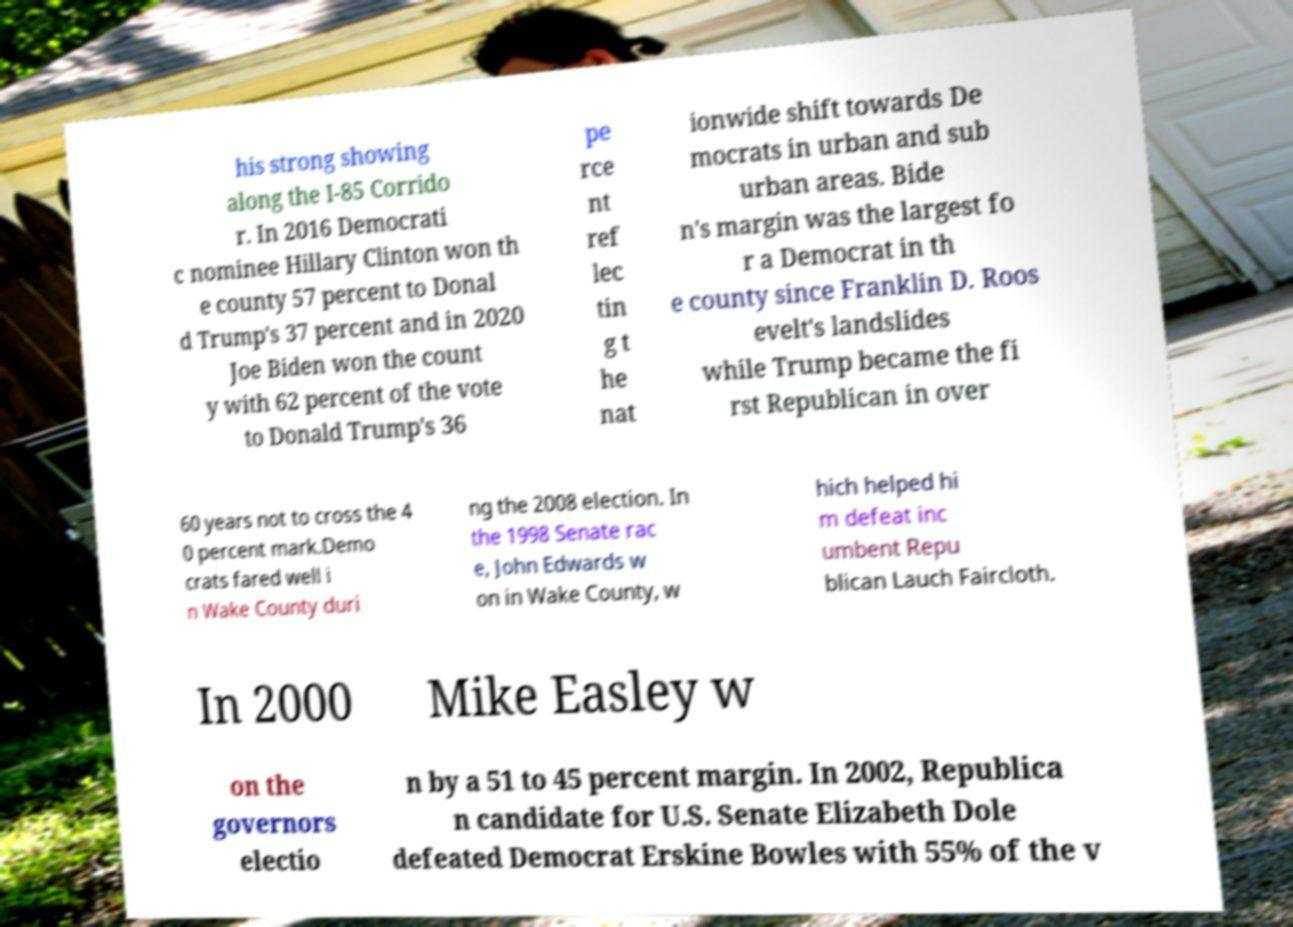Could you extract and type out the text from this image? his strong showing along the I-85 Corrido r. In 2016 Democrati c nominee Hillary Clinton won th e county 57 percent to Donal d Trump's 37 percent and in 2020 Joe Biden won the count y with 62 percent of the vote to Donald Trump's 36 pe rce nt ref lec tin g t he nat ionwide shift towards De mocrats in urban and sub urban areas. Bide n's margin was the largest fo r a Democrat in th e county since Franklin D. Roos evelt's landslides while Trump became the fi rst Republican in over 60 years not to cross the 4 0 percent mark.Demo crats fared well i n Wake County duri ng the 2008 election. In the 1998 Senate rac e, John Edwards w on in Wake County, w hich helped hi m defeat inc umbent Repu blican Lauch Faircloth. In 2000 Mike Easley w on the governors electio n by a 51 to 45 percent margin. In 2002, Republica n candidate for U.S. Senate Elizabeth Dole defeated Democrat Erskine Bowles with 55% of the v 